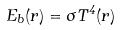<formula> <loc_0><loc_0><loc_500><loc_500>E _ { b } ( r ) = \sigma T ^ { 4 } ( r )</formula> 